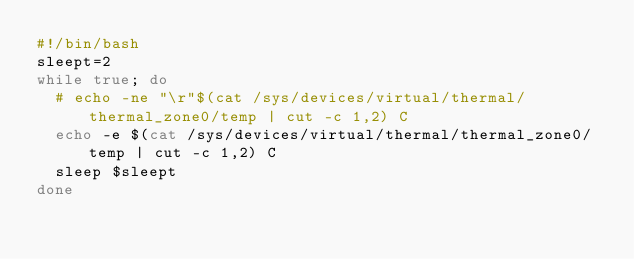<code> <loc_0><loc_0><loc_500><loc_500><_Bash_>#!/bin/bash
sleept=2
while true; do
  # echo -ne "\r"$(cat /sys/devices/virtual/thermal/thermal_zone0/temp | cut -c 1,2) C
  echo -e $(cat /sys/devices/virtual/thermal/thermal_zone0/temp | cut -c 1,2) C
  sleep $sleept
done
</code> 